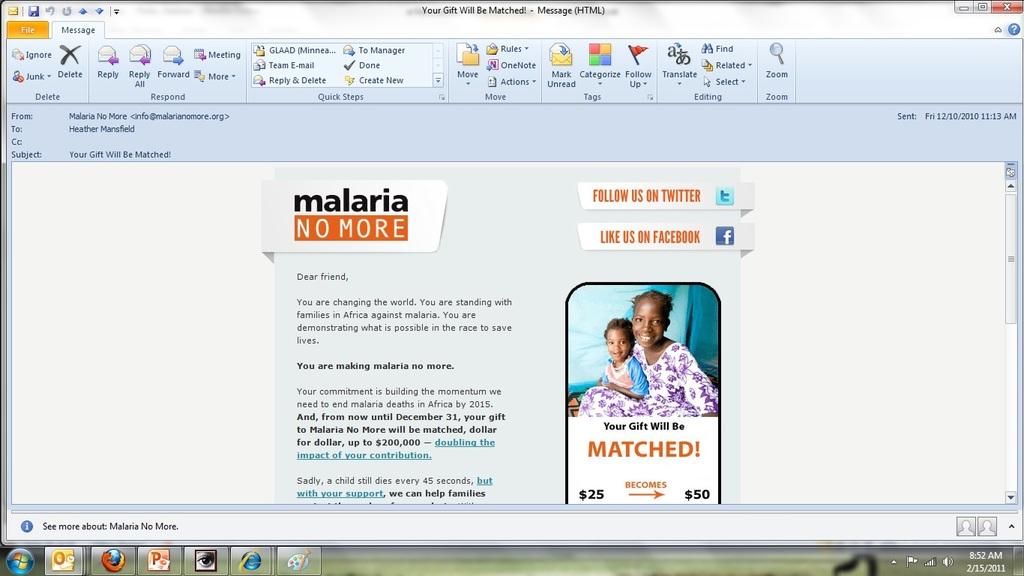What disease is mentioned on the web page?
Offer a terse response. Malaria. What is the date on the bottom right?
Keep it short and to the point. 2/15/2011. 